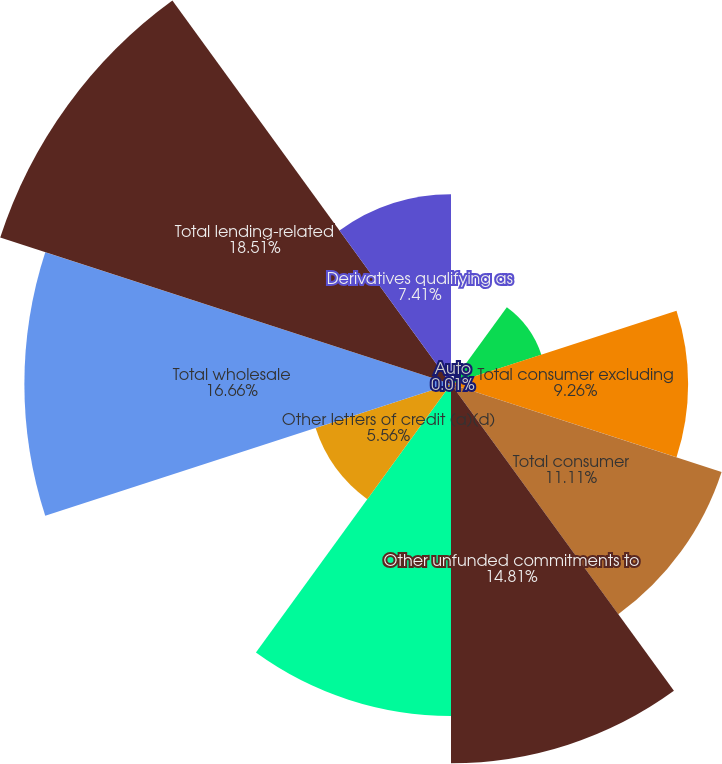Convert chart. <chart><loc_0><loc_0><loc_500><loc_500><pie_chart><fcel>Auto<fcel>Business banking<fcel>Total consumer excluding<fcel>Total consumer<fcel>Other unfunded commitments to<fcel>Standby letters of credit and<fcel>Other letters of credit (a)(d)<fcel>Total wholesale<fcel>Total lending-related<fcel>Derivatives qualifying as<nl><fcel>0.01%<fcel>3.71%<fcel>9.26%<fcel>11.11%<fcel>14.81%<fcel>12.96%<fcel>5.56%<fcel>16.66%<fcel>18.51%<fcel>7.41%<nl></chart> 